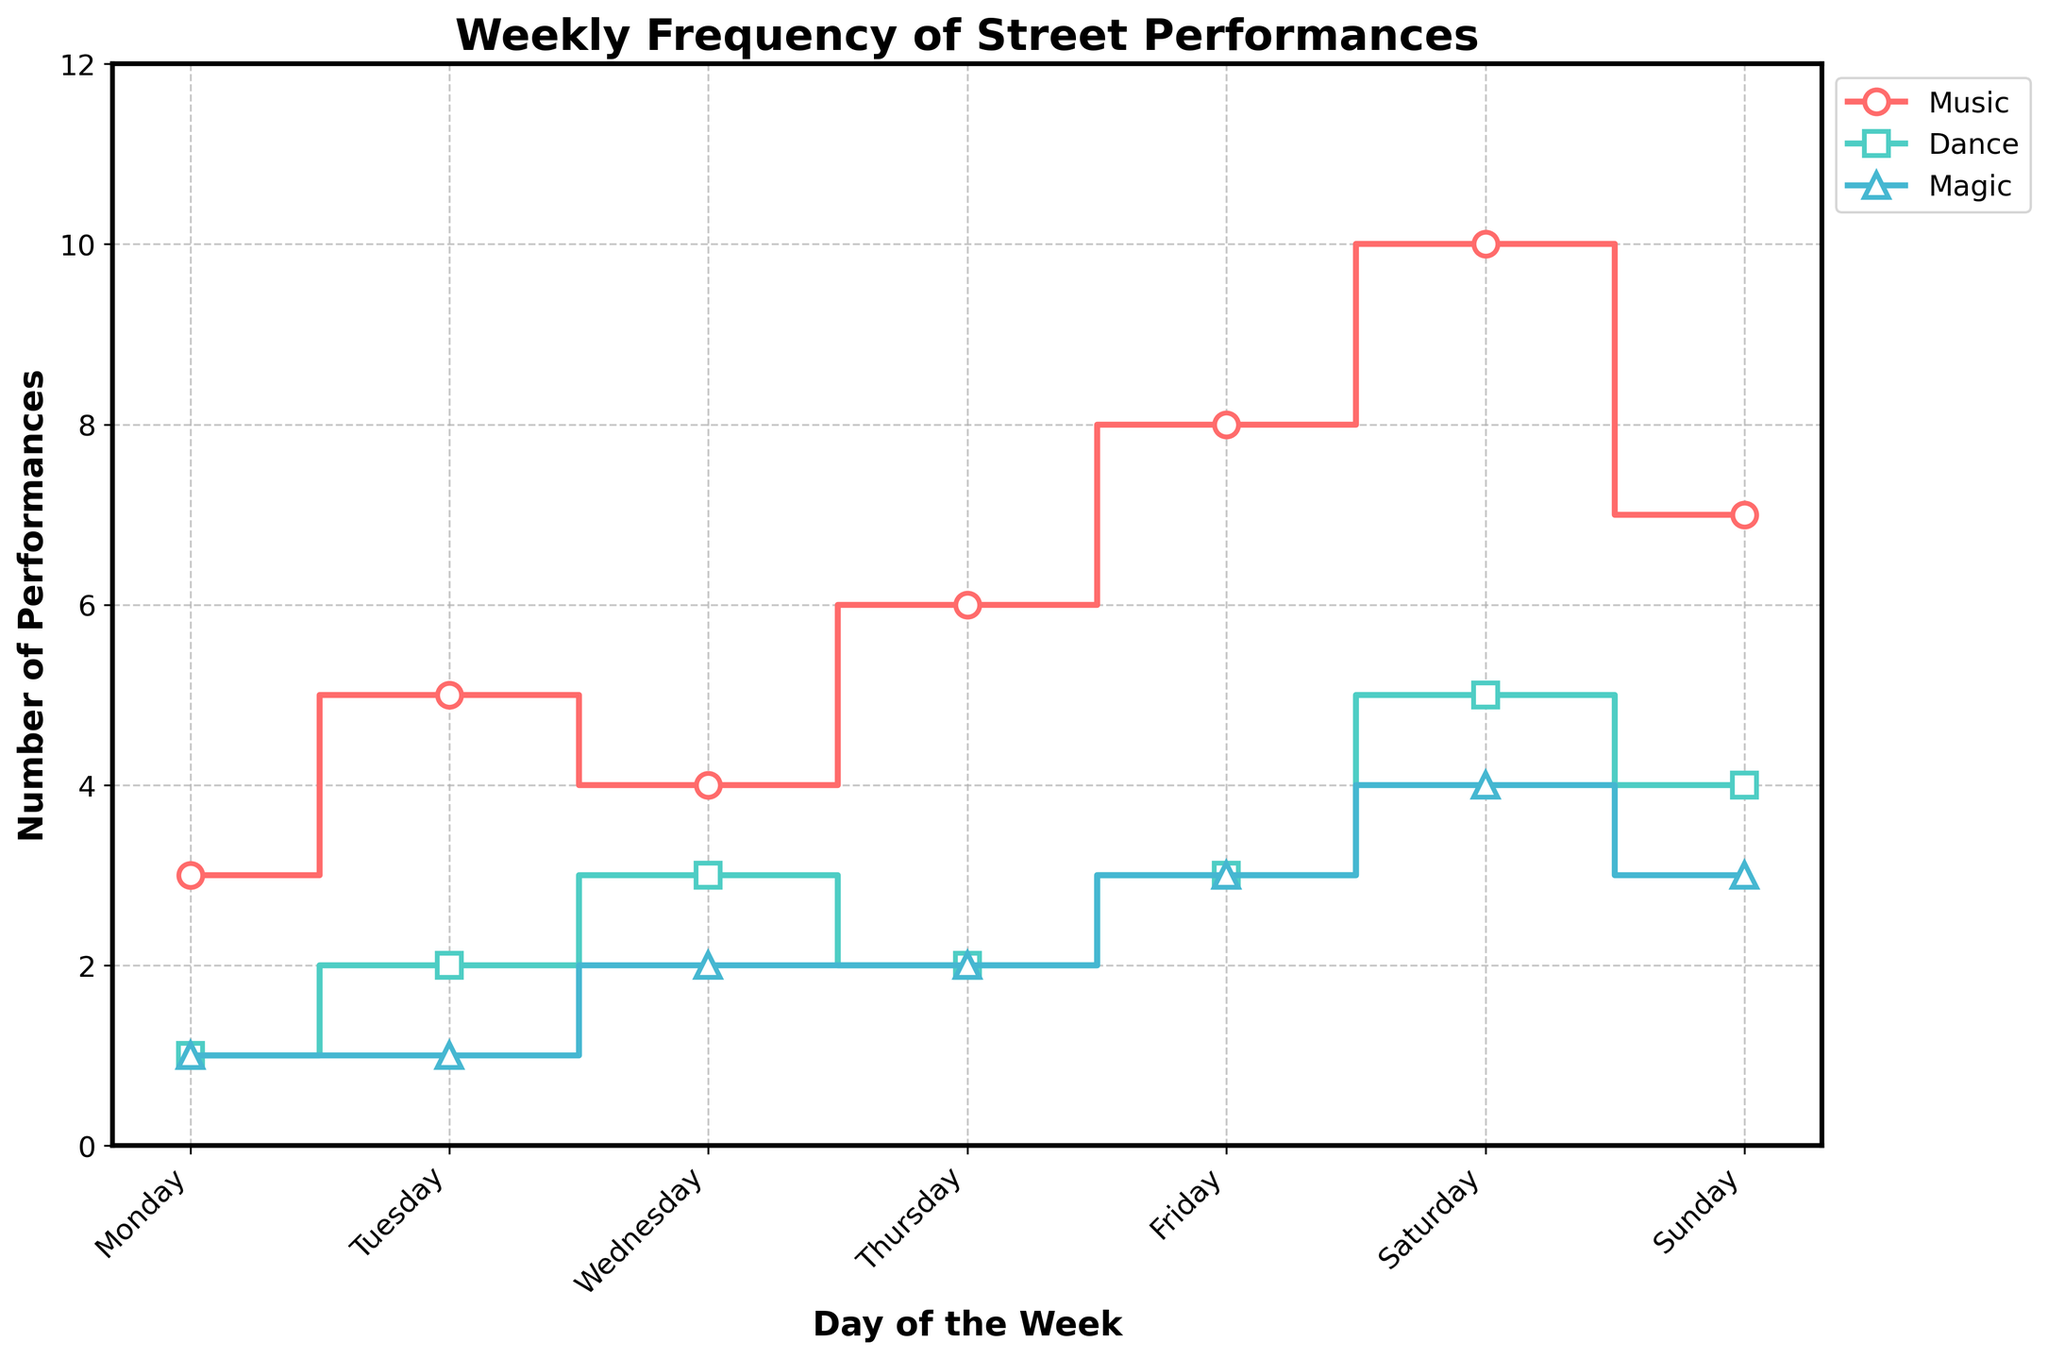What is the title of the figure? The title is usually placed at the top of the figure. From there, you can read the title directly.
Answer: Weekly Frequency of Street Performances How many different types of street performances are represented in the figure? The figure uses different colors and markers to distinguish between the types of performances. Observing the legend, you can count the different types.
Answer: Three On which day is the frequency of Music performances the highest? The Music performances are represented by one of the lines. Following that line to its peak value, you can see that it is highest on Saturday.
Answer: Saturday How many Magic performances occurred on Wednesday? The Magic performances are indicated by a distinct line. By following this line to Wednesday, you can read the count at that point.
Answer: Two Which type of street performance is most frequent on Sunday? By comparing the counts of all types of performances on Sunday, you can determine which has the highest value. Music performance has the highest count on Sunday.
Answer: Music What is the total number of Dance performances over the week? Add up the counts for Dance performances from each day. The counts are 1 + 2 + 3 + 2 + 3 + 5 + 4 = 20.
Answer: 20 Which day has the least number of total performances combined? You need to sum the counts of all types of performances for each day and compare. Monday has counts of 3 (Music) + 1 (Dance) + 1 (Magic) = 5, which is the smallest summed value.
Answer: Monday Is the number of Dance performances on Friday greater than the number of Magic performances on Tuesday? Compare the count of Dance performances on Friday, which is 3, with the count of Magic performances on Tuesday, which is 1.
Answer: Yes Between Dance and Magic performances, which type has a greater total count over the week? Sum the counts for Dance (1 + 2 + 3 + 2 + 3 + 5 + 4 = 20) and Magic (1 + 1 + 2 + 2 + 3 + 4 + 3 = 16). Dance has the greater total count.
Answer: Dance What is the average number of Music performances over the week? Sum the counts for Music performances (3 + 5 + 4 + 6 + 8 + 10 + 7 = 43) and divide by 7. The average is 43/7 ≈ 6.14.
Answer: 6.14 